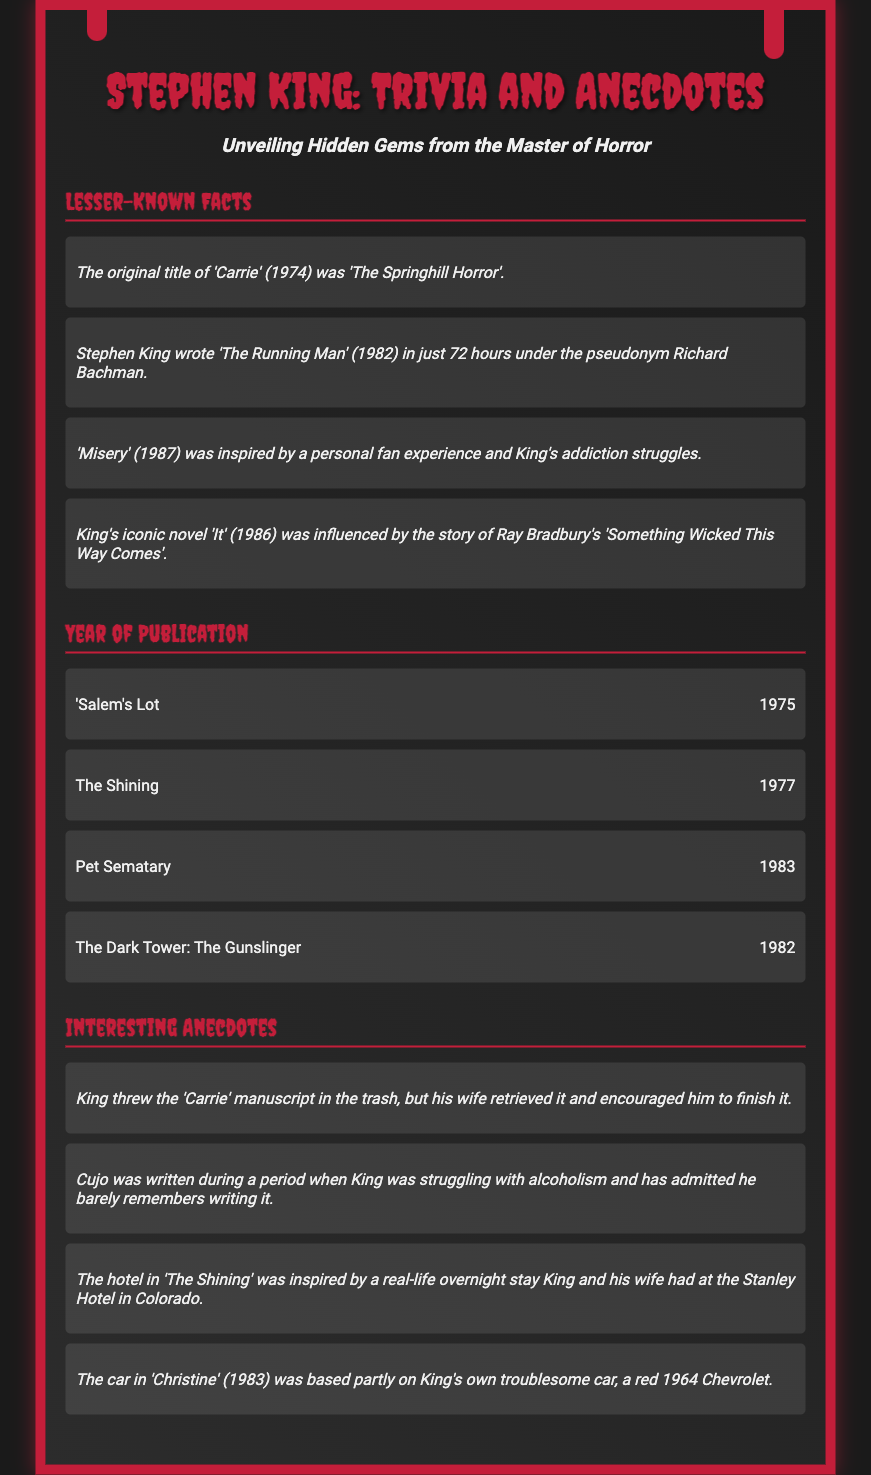what was the original title of 'Carrie'? The document states that the original title was 'The Springhill Horror'.
Answer: The Springhill Horror how long did it take Stephen King to write 'The Running Man'? According to the document, it took him just 72 hours.
Answer: 72 hours in what year was 'Misery' published? The document lists the publication year of 'Misery' as 1987.
Answer: 1987 what inspired King's 'The Shining'? The anecdote notes that it was inspired by the Stanley Hotel in Colorado.
Answer: Stanley Hotel which novel was influenced by Ray Bradbury's work? The document mentions that 'It' was influenced by 'Something Wicked This Way Comes'.
Answer: It 